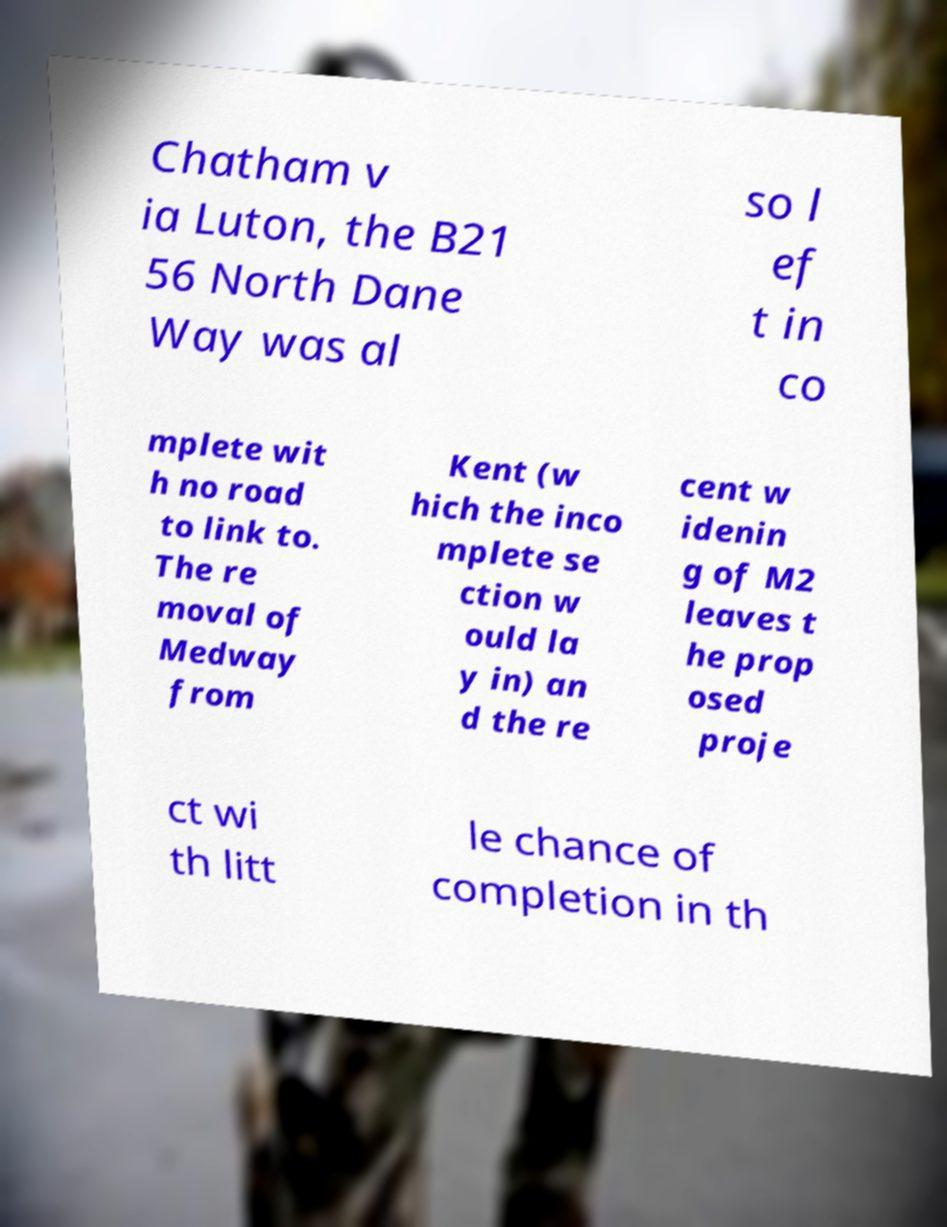Please identify and transcribe the text found in this image. Chatham v ia Luton, the B21 56 North Dane Way was al so l ef t in co mplete wit h no road to link to. The re moval of Medway from Kent (w hich the inco mplete se ction w ould la y in) an d the re cent w idenin g of M2 leaves t he prop osed proje ct wi th litt le chance of completion in th 